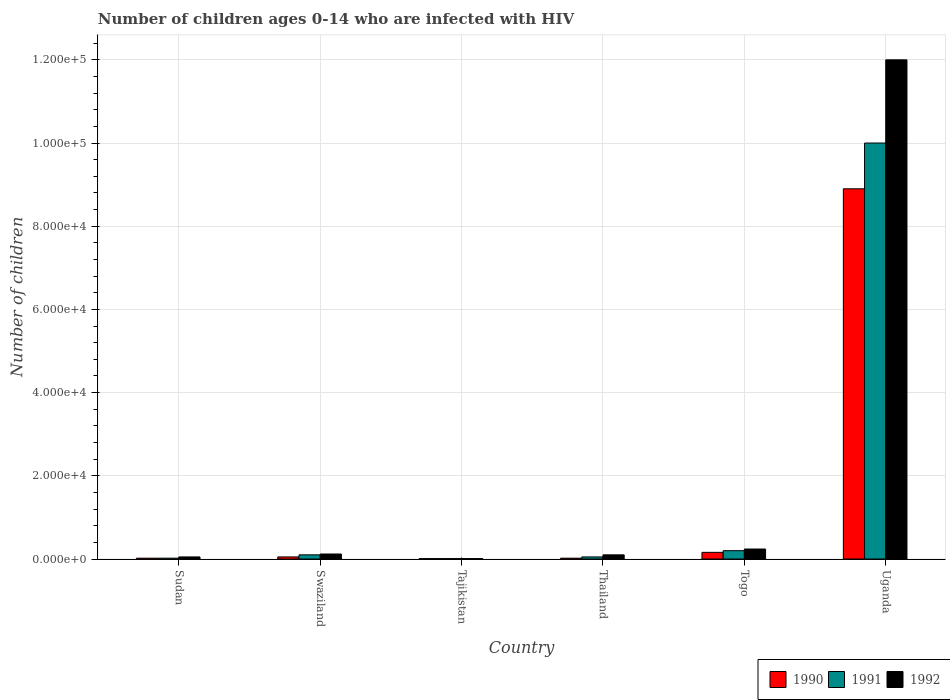How many different coloured bars are there?
Your response must be concise. 3. How many groups of bars are there?
Your answer should be compact. 6. Are the number of bars per tick equal to the number of legend labels?
Your answer should be compact. Yes. Are the number of bars on each tick of the X-axis equal?
Offer a very short reply. Yes. How many bars are there on the 6th tick from the left?
Provide a succinct answer. 3. What is the label of the 1st group of bars from the left?
Give a very brief answer. Sudan. In how many cases, is the number of bars for a given country not equal to the number of legend labels?
Offer a terse response. 0. Across all countries, what is the maximum number of HIV infected children in 1992?
Make the answer very short. 1.20e+05. Across all countries, what is the minimum number of HIV infected children in 1991?
Offer a very short reply. 100. In which country was the number of HIV infected children in 1992 maximum?
Provide a succinct answer. Uganda. In which country was the number of HIV infected children in 1990 minimum?
Offer a terse response. Tajikistan. What is the total number of HIV infected children in 1991 in the graph?
Give a very brief answer. 1.04e+05. What is the difference between the number of HIV infected children in 1990 in Sudan and that in Togo?
Provide a succinct answer. -1400. What is the difference between the number of HIV infected children in 1991 in Thailand and the number of HIV infected children in 1992 in Sudan?
Provide a short and direct response. 0. What is the average number of HIV infected children in 1991 per country?
Make the answer very short. 1.73e+04. What is the difference between the number of HIV infected children of/in 1991 and number of HIV infected children of/in 1990 in Thailand?
Your answer should be very brief. 300. In how many countries, is the number of HIV infected children in 1992 greater than 100000?
Your answer should be compact. 1. What is the ratio of the number of HIV infected children in 1992 in Sudan to that in Togo?
Your answer should be very brief. 0.21. Is the number of HIV infected children in 1991 in Swaziland less than that in Uganda?
Give a very brief answer. Yes. Is the difference between the number of HIV infected children in 1991 in Sudan and Thailand greater than the difference between the number of HIV infected children in 1990 in Sudan and Thailand?
Make the answer very short. No. What is the difference between the highest and the second highest number of HIV infected children in 1990?
Your answer should be very brief. 8.74e+04. What is the difference between the highest and the lowest number of HIV infected children in 1991?
Ensure brevity in your answer.  9.99e+04. In how many countries, is the number of HIV infected children in 1991 greater than the average number of HIV infected children in 1991 taken over all countries?
Offer a terse response. 1. What does the 1st bar from the left in Thailand represents?
Offer a very short reply. 1990. Is it the case that in every country, the sum of the number of HIV infected children in 1992 and number of HIV infected children in 1990 is greater than the number of HIV infected children in 1991?
Your answer should be compact. Yes. How many bars are there?
Make the answer very short. 18. Are all the bars in the graph horizontal?
Your answer should be very brief. No. How many countries are there in the graph?
Your answer should be very brief. 6. Are the values on the major ticks of Y-axis written in scientific E-notation?
Your response must be concise. Yes. Does the graph contain any zero values?
Offer a terse response. No. Does the graph contain grids?
Give a very brief answer. Yes. Where does the legend appear in the graph?
Ensure brevity in your answer.  Bottom right. How many legend labels are there?
Your answer should be compact. 3. How are the legend labels stacked?
Your answer should be compact. Horizontal. What is the title of the graph?
Ensure brevity in your answer.  Number of children ages 0-14 who are infected with HIV. Does "1971" appear as one of the legend labels in the graph?
Your answer should be very brief. No. What is the label or title of the Y-axis?
Make the answer very short. Number of children. What is the Number of children of 1991 in Sudan?
Your response must be concise. 200. What is the Number of children in 1990 in Swaziland?
Ensure brevity in your answer.  500. What is the Number of children of 1992 in Swaziland?
Keep it short and to the point. 1200. What is the Number of children in 1990 in Tajikistan?
Your answer should be compact. 100. What is the Number of children in 1991 in Tajikistan?
Your answer should be compact. 100. What is the Number of children in 1990 in Thailand?
Offer a terse response. 200. What is the Number of children in 1990 in Togo?
Your response must be concise. 1600. What is the Number of children of 1991 in Togo?
Your answer should be very brief. 2000. What is the Number of children in 1992 in Togo?
Provide a short and direct response. 2400. What is the Number of children of 1990 in Uganda?
Make the answer very short. 8.90e+04. What is the Number of children of 1992 in Uganda?
Keep it short and to the point. 1.20e+05. Across all countries, what is the maximum Number of children in 1990?
Your answer should be very brief. 8.90e+04. Across all countries, what is the maximum Number of children in 1991?
Your response must be concise. 1.00e+05. Across all countries, what is the minimum Number of children of 1991?
Your answer should be very brief. 100. Across all countries, what is the minimum Number of children of 1992?
Provide a short and direct response. 100. What is the total Number of children of 1990 in the graph?
Give a very brief answer. 9.16e+04. What is the total Number of children in 1991 in the graph?
Keep it short and to the point. 1.04e+05. What is the total Number of children of 1992 in the graph?
Provide a succinct answer. 1.25e+05. What is the difference between the Number of children of 1990 in Sudan and that in Swaziland?
Keep it short and to the point. -300. What is the difference between the Number of children in 1991 in Sudan and that in Swaziland?
Provide a succinct answer. -800. What is the difference between the Number of children in 1992 in Sudan and that in Swaziland?
Your response must be concise. -700. What is the difference between the Number of children in 1990 in Sudan and that in Tajikistan?
Your answer should be compact. 100. What is the difference between the Number of children of 1991 in Sudan and that in Thailand?
Your answer should be compact. -300. What is the difference between the Number of children in 1992 in Sudan and that in Thailand?
Offer a terse response. -500. What is the difference between the Number of children of 1990 in Sudan and that in Togo?
Provide a short and direct response. -1400. What is the difference between the Number of children in 1991 in Sudan and that in Togo?
Make the answer very short. -1800. What is the difference between the Number of children of 1992 in Sudan and that in Togo?
Offer a terse response. -1900. What is the difference between the Number of children in 1990 in Sudan and that in Uganda?
Give a very brief answer. -8.88e+04. What is the difference between the Number of children of 1991 in Sudan and that in Uganda?
Make the answer very short. -9.98e+04. What is the difference between the Number of children in 1992 in Sudan and that in Uganda?
Offer a very short reply. -1.20e+05. What is the difference between the Number of children of 1990 in Swaziland and that in Tajikistan?
Offer a terse response. 400. What is the difference between the Number of children of 1991 in Swaziland and that in Tajikistan?
Offer a terse response. 900. What is the difference between the Number of children in 1992 in Swaziland and that in Tajikistan?
Give a very brief answer. 1100. What is the difference between the Number of children of 1990 in Swaziland and that in Thailand?
Make the answer very short. 300. What is the difference between the Number of children in 1990 in Swaziland and that in Togo?
Give a very brief answer. -1100. What is the difference between the Number of children in 1991 in Swaziland and that in Togo?
Make the answer very short. -1000. What is the difference between the Number of children in 1992 in Swaziland and that in Togo?
Keep it short and to the point. -1200. What is the difference between the Number of children in 1990 in Swaziland and that in Uganda?
Ensure brevity in your answer.  -8.85e+04. What is the difference between the Number of children in 1991 in Swaziland and that in Uganda?
Provide a short and direct response. -9.90e+04. What is the difference between the Number of children in 1992 in Swaziland and that in Uganda?
Give a very brief answer. -1.19e+05. What is the difference between the Number of children in 1990 in Tajikistan and that in Thailand?
Your answer should be compact. -100. What is the difference between the Number of children of 1991 in Tajikistan and that in Thailand?
Your answer should be very brief. -400. What is the difference between the Number of children of 1992 in Tajikistan and that in Thailand?
Make the answer very short. -900. What is the difference between the Number of children in 1990 in Tajikistan and that in Togo?
Provide a succinct answer. -1500. What is the difference between the Number of children of 1991 in Tajikistan and that in Togo?
Offer a very short reply. -1900. What is the difference between the Number of children of 1992 in Tajikistan and that in Togo?
Provide a short and direct response. -2300. What is the difference between the Number of children of 1990 in Tajikistan and that in Uganda?
Ensure brevity in your answer.  -8.89e+04. What is the difference between the Number of children of 1991 in Tajikistan and that in Uganda?
Offer a terse response. -9.99e+04. What is the difference between the Number of children in 1992 in Tajikistan and that in Uganda?
Provide a succinct answer. -1.20e+05. What is the difference between the Number of children of 1990 in Thailand and that in Togo?
Your response must be concise. -1400. What is the difference between the Number of children in 1991 in Thailand and that in Togo?
Offer a very short reply. -1500. What is the difference between the Number of children in 1992 in Thailand and that in Togo?
Offer a terse response. -1400. What is the difference between the Number of children in 1990 in Thailand and that in Uganda?
Offer a very short reply. -8.88e+04. What is the difference between the Number of children of 1991 in Thailand and that in Uganda?
Offer a terse response. -9.95e+04. What is the difference between the Number of children in 1992 in Thailand and that in Uganda?
Provide a short and direct response. -1.19e+05. What is the difference between the Number of children in 1990 in Togo and that in Uganda?
Your answer should be compact. -8.74e+04. What is the difference between the Number of children of 1991 in Togo and that in Uganda?
Make the answer very short. -9.80e+04. What is the difference between the Number of children in 1992 in Togo and that in Uganda?
Provide a short and direct response. -1.18e+05. What is the difference between the Number of children of 1990 in Sudan and the Number of children of 1991 in Swaziland?
Your answer should be compact. -800. What is the difference between the Number of children in 1990 in Sudan and the Number of children in 1992 in Swaziland?
Your answer should be very brief. -1000. What is the difference between the Number of children of 1991 in Sudan and the Number of children of 1992 in Swaziland?
Your response must be concise. -1000. What is the difference between the Number of children in 1990 in Sudan and the Number of children in 1991 in Tajikistan?
Keep it short and to the point. 100. What is the difference between the Number of children of 1991 in Sudan and the Number of children of 1992 in Tajikistan?
Your answer should be very brief. 100. What is the difference between the Number of children in 1990 in Sudan and the Number of children in 1991 in Thailand?
Offer a very short reply. -300. What is the difference between the Number of children of 1990 in Sudan and the Number of children of 1992 in Thailand?
Offer a terse response. -800. What is the difference between the Number of children of 1991 in Sudan and the Number of children of 1992 in Thailand?
Keep it short and to the point. -800. What is the difference between the Number of children of 1990 in Sudan and the Number of children of 1991 in Togo?
Offer a terse response. -1800. What is the difference between the Number of children in 1990 in Sudan and the Number of children in 1992 in Togo?
Your answer should be very brief. -2200. What is the difference between the Number of children in 1991 in Sudan and the Number of children in 1992 in Togo?
Provide a succinct answer. -2200. What is the difference between the Number of children in 1990 in Sudan and the Number of children in 1991 in Uganda?
Your answer should be compact. -9.98e+04. What is the difference between the Number of children of 1990 in Sudan and the Number of children of 1992 in Uganda?
Your answer should be compact. -1.20e+05. What is the difference between the Number of children of 1991 in Sudan and the Number of children of 1992 in Uganda?
Your response must be concise. -1.20e+05. What is the difference between the Number of children of 1990 in Swaziland and the Number of children of 1992 in Tajikistan?
Provide a succinct answer. 400. What is the difference between the Number of children in 1991 in Swaziland and the Number of children in 1992 in Tajikistan?
Provide a succinct answer. 900. What is the difference between the Number of children in 1990 in Swaziland and the Number of children in 1992 in Thailand?
Your answer should be very brief. -500. What is the difference between the Number of children of 1991 in Swaziland and the Number of children of 1992 in Thailand?
Your answer should be very brief. 0. What is the difference between the Number of children in 1990 in Swaziland and the Number of children in 1991 in Togo?
Give a very brief answer. -1500. What is the difference between the Number of children in 1990 in Swaziland and the Number of children in 1992 in Togo?
Keep it short and to the point. -1900. What is the difference between the Number of children in 1991 in Swaziland and the Number of children in 1992 in Togo?
Provide a short and direct response. -1400. What is the difference between the Number of children in 1990 in Swaziland and the Number of children in 1991 in Uganda?
Offer a very short reply. -9.95e+04. What is the difference between the Number of children in 1990 in Swaziland and the Number of children in 1992 in Uganda?
Offer a terse response. -1.20e+05. What is the difference between the Number of children in 1991 in Swaziland and the Number of children in 1992 in Uganda?
Your response must be concise. -1.19e+05. What is the difference between the Number of children of 1990 in Tajikistan and the Number of children of 1991 in Thailand?
Ensure brevity in your answer.  -400. What is the difference between the Number of children in 1990 in Tajikistan and the Number of children in 1992 in Thailand?
Offer a very short reply. -900. What is the difference between the Number of children of 1991 in Tajikistan and the Number of children of 1992 in Thailand?
Give a very brief answer. -900. What is the difference between the Number of children in 1990 in Tajikistan and the Number of children in 1991 in Togo?
Your answer should be compact. -1900. What is the difference between the Number of children of 1990 in Tajikistan and the Number of children of 1992 in Togo?
Provide a short and direct response. -2300. What is the difference between the Number of children in 1991 in Tajikistan and the Number of children in 1992 in Togo?
Keep it short and to the point. -2300. What is the difference between the Number of children of 1990 in Tajikistan and the Number of children of 1991 in Uganda?
Provide a short and direct response. -9.99e+04. What is the difference between the Number of children of 1990 in Tajikistan and the Number of children of 1992 in Uganda?
Your answer should be very brief. -1.20e+05. What is the difference between the Number of children in 1991 in Tajikistan and the Number of children in 1992 in Uganda?
Offer a terse response. -1.20e+05. What is the difference between the Number of children of 1990 in Thailand and the Number of children of 1991 in Togo?
Make the answer very short. -1800. What is the difference between the Number of children in 1990 in Thailand and the Number of children in 1992 in Togo?
Your answer should be compact. -2200. What is the difference between the Number of children in 1991 in Thailand and the Number of children in 1992 in Togo?
Provide a short and direct response. -1900. What is the difference between the Number of children in 1990 in Thailand and the Number of children in 1991 in Uganda?
Ensure brevity in your answer.  -9.98e+04. What is the difference between the Number of children in 1990 in Thailand and the Number of children in 1992 in Uganda?
Give a very brief answer. -1.20e+05. What is the difference between the Number of children in 1991 in Thailand and the Number of children in 1992 in Uganda?
Provide a succinct answer. -1.20e+05. What is the difference between the Number of children in 1990 in Togo and the Number of children in 1991 in Uganda?
Offer a very short reply. -9.84e+04. What is the difference between the Number of children in 1990 in Togo and the Number of children in 1992 in Uganda?
Your answer should be very brief. -1.18e+05. What is the difference between the Number of children in 1991 in Togo and the Number of children in 1992 in Uganda?
Your answer should be compact. -1.18e+05. What is the average Number of children in 1990 per country?
Keep it short and to the point. 1.53e+04. What is the average Number of children in 1991 per country?
Your response must be concise. 1.73e+04. What is the average Number of children of 1992 per country?
Give a very brief answer. 2.09e+04. What is the difference between the Number of children in 1990 and Number of children in 1992 in Sudan?
Keep it short and to the point. -300. What is the difference between the Number of children of 1991 and Number of children of 1992 in Sudan?
Ensure brevity in your answer.  -300. What is the difference between the Number of children of 1990 and Number of children of 1991 in Swaziland?
Your response must be concise. -500. What is the difference between the Number of children in 1990 and Number of children in 1992 in Swaziland?
Offer a very short reply. -700. What is the difference between the Number of children in 1991 and Number of children in 1992 in Swaziland?
Your answer should be compact. -200. What is the difference between the Number of children of 1990 and Number of children of 1992 in Tajikistan?
Provide a short and direct response. 0. What is the difference between the Number of children in 1991 and Number of children in 1992 in Tajikistan?
Provide a succinct answer. 0. What is the difference between the Number of children in 1990 and Number of children in 1991 in Thailand?
Your answer should be compact. -300. What is the difference between the Number of children of 1990 and Number of children of 1992 in Thailand?
Offer a very short reply. -800. What is the difference between the Number of children in 1991 and Number of children in 1992 in Thailand?
Offer a terse response. -500. What is the difference between the Number of children in 1990 and Number of children in 1991 in Togo?
Your response must be concise. -400. What is the difference between the Number of children of 1990 and Number of children of 1992 in Togo?
Make the answer very short. -800. What is the difference between the Number of children of 1991 and Number of children of 1992 in Togo?
Your answer should be compact. -400. What is the difference between the Number of children of 1990 and Number of children of 1991 in Uganda?
Your response must be concise. -1.10e+04. What is the difference between the Number of children in 1990 and Number of children in 1992 in Uganda?
Your response must be concise. -3.10e+04. What is the ratio of the Number of children of 1991 in Sudan to that in Swaziland?
Provide a succinct answer. 0.2. What is the ratio of the Number of children of 1992 in Sudan to that in Swaziland?
Give a very brief answer. 0.42. What is the ratio of the Number of children in 1990 in Sudan to that in Tajikistan?
Give a very brief answer. 2. What is the ratio of the Number of children in 1990 in Sudan to that in Thailand?
Provide a succinct answer. 1. What is the ratio of the Number of children of 1992 in Sudan to that in Thailand?
Your response must be concise. 0.5. What is the ratio of the Number of children in 1991 in Sudan to that in Togo?
Provide a succinct answer. 0.1. What is the ratio of the Number of children in 1992 in Sudan to that in Togo?
Make the answer very short. 0.21. What is the ratio of the Number of children in 1990 in Sudan to that in Uganda?
Your answer should be compact. 0. What is the ratio of the Number of children of 1991 in Sudan to that in Uganda?
Give a very brief answer. 0. What is the ratio of the Number of children of 1992 in Sudan to that in Uganda?
Your response must be concise. 0. What is the ratio of the Number of children in 1990 in Swaziland to that in Tajikistan?
Offer a very short reply. 5. What is the ratio of the Number of children of 1992 in Swaziland to that in Tajikistan?
Ensure brevity in your answer.  12. What is the ratio of the Number of children of 1991 in Swaziland to that in Thailand?
Offer a terse response. 2. What is the ratio of the Number of children of 1990 in Swaziland to that in Togo?
Provide a succinct answer. 0.31. What is the ratio of the Number of children in 1991 in Swaziland to that in Togo?
Make the answer very short. 0.5. What is the ratio of the Number of children of 1992 in Swaziland to that in Togo?
Your answer should be very brief. 0.5. What is the ratio of the Number of children in 1990 in Swaziland to that in Uganda?
Your answer should be compact. 0.01. What is the ratio of the Number of children of 1991 in Swaziland to that in Uganda?
Your response must be concise. 0.01. What is the ratio of the Number of children of 1992 in Tajikistan to that in Thailand?
Your response must be concise. 0.1. What is the ratio of the Number of children of 1990 in Tajikistan to that in Togo?
Give a very brief answer. 0.06. What is the ratio of the Number of children of 1991 in Tajikistan to that in Togo?
Your response must be concise. 0.05. What is the ratio of the Number of children of 1992 in Tajikistan to that in Togo?
Your answer should be very brief. 0.04. What is the ratio of the Number of children in 1990 in Tajikistan to that in Uganda?
Offer a terse response. 0. What is the ratio of the Number of children in 1992 in Tajikistan to that in Uganda?
Offer a terse response. 0. What is the ratio of the Number of children in 1990 in Thailand to that in Togo?
Keep it short and to the point. 0.12. What is the ratio of the Number of children in 1992 in Thailand to that in Togo?
Offer a very short reply. 0.42. What is the ratio of the Number of children in 1990 in Thailand to that in Uganda?
Provide a succinct answer. 0. What is the ratio of the Number of children in 1991 in Thailand to that in Uganda?
Provide a succinct answer. 0.01. What is the ratio of the Number of children in 1992 in Thailand to that in Uganda?
Give a very brief answer. 0.01. What is the ratio of the Number of children in 1990 in Togo to that in Uganda?
Provide a succinct answer. 0.02. What is the ratio of the Number of children in 1992 in Togo to that in Uganda?
Your response must be concise. 0.02. What is the difference between the highest and the second highest Number of children in 1990?
Your response must be concise. 8.74e+04. What is the difference between the highest and the second highest Number of children in 1991?
Give a very brief answer. 9.80e+04. What is the difference between the highest and the second highest Number of children in 1992?
Keep it short and to the point. 1.18e+05. What is the difference between the highest and the lowest Number of children in 1990?
Make the answer very short. 8.89e+04. What is the difference between the highest and the lowest Number of children in 1991?
Provide a short and direct response. 9.99e+04. What is the difference between the highest and the lowest Number of children of 1992?
Your answer should be very brief. 1.20e+05. 